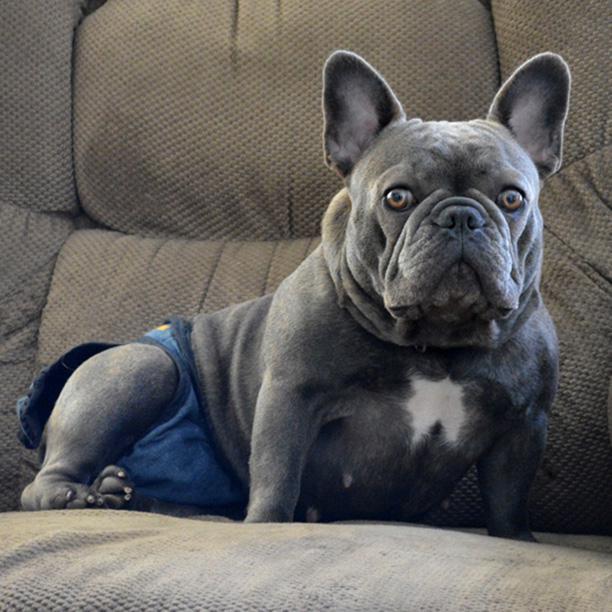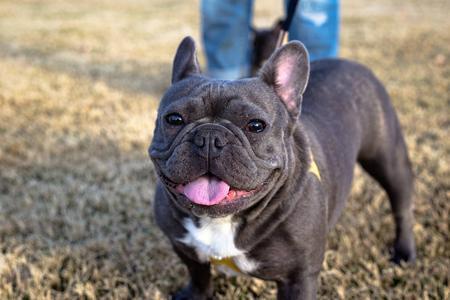The first image is the image on the left, the second image is the image on the right. Given the left and right images, does the statement "The dog in the right image has its mouth open and its tongue out." hold true? Answer yes or no. Yes. The first image is the image on the left, the second image is the image on the right. Analyze the images presented: Is the assertion "The dog in the image on the right is standing up on all four feet." valid? Answer yes or no. Yes. The first image is the image on the left, the second image is the image on the right. For the images shown, is this caption "The left image shows a grey bulldog in front of a gray background, and the right image shows a grey bulldog sitting in front of something bright orange." true? Answer yes or no. No. The first image is the image on the left, the second image is the image on the right. Considering the images on both sides, is "A dog is standing on grass in one image and a dog is on the couch in the other." valid? Answer yes or no. Yes. 